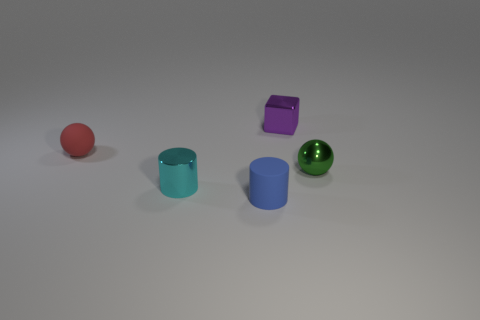Add 3 small yellow cylinders. How many objects exist? 8 Subtract all cubes. How many objects are left? 4 Subtract 1 red spheres. How many objects are left? 4 Subtract all tiny blue cylinders. Subtract all rubber things. How many objects are left? 2 Add 1 small purple metallic blocks. How many small purple metallic blocks are left? 2 Add 2 tiny cylinders. How many tiny cylinders exist? 4 